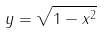Convert formula to latex. <formula><loc_0><loc_0><loc_500><loc_500>y = { \sqrt { 1 - x ^ { 2 } } }</formula> 